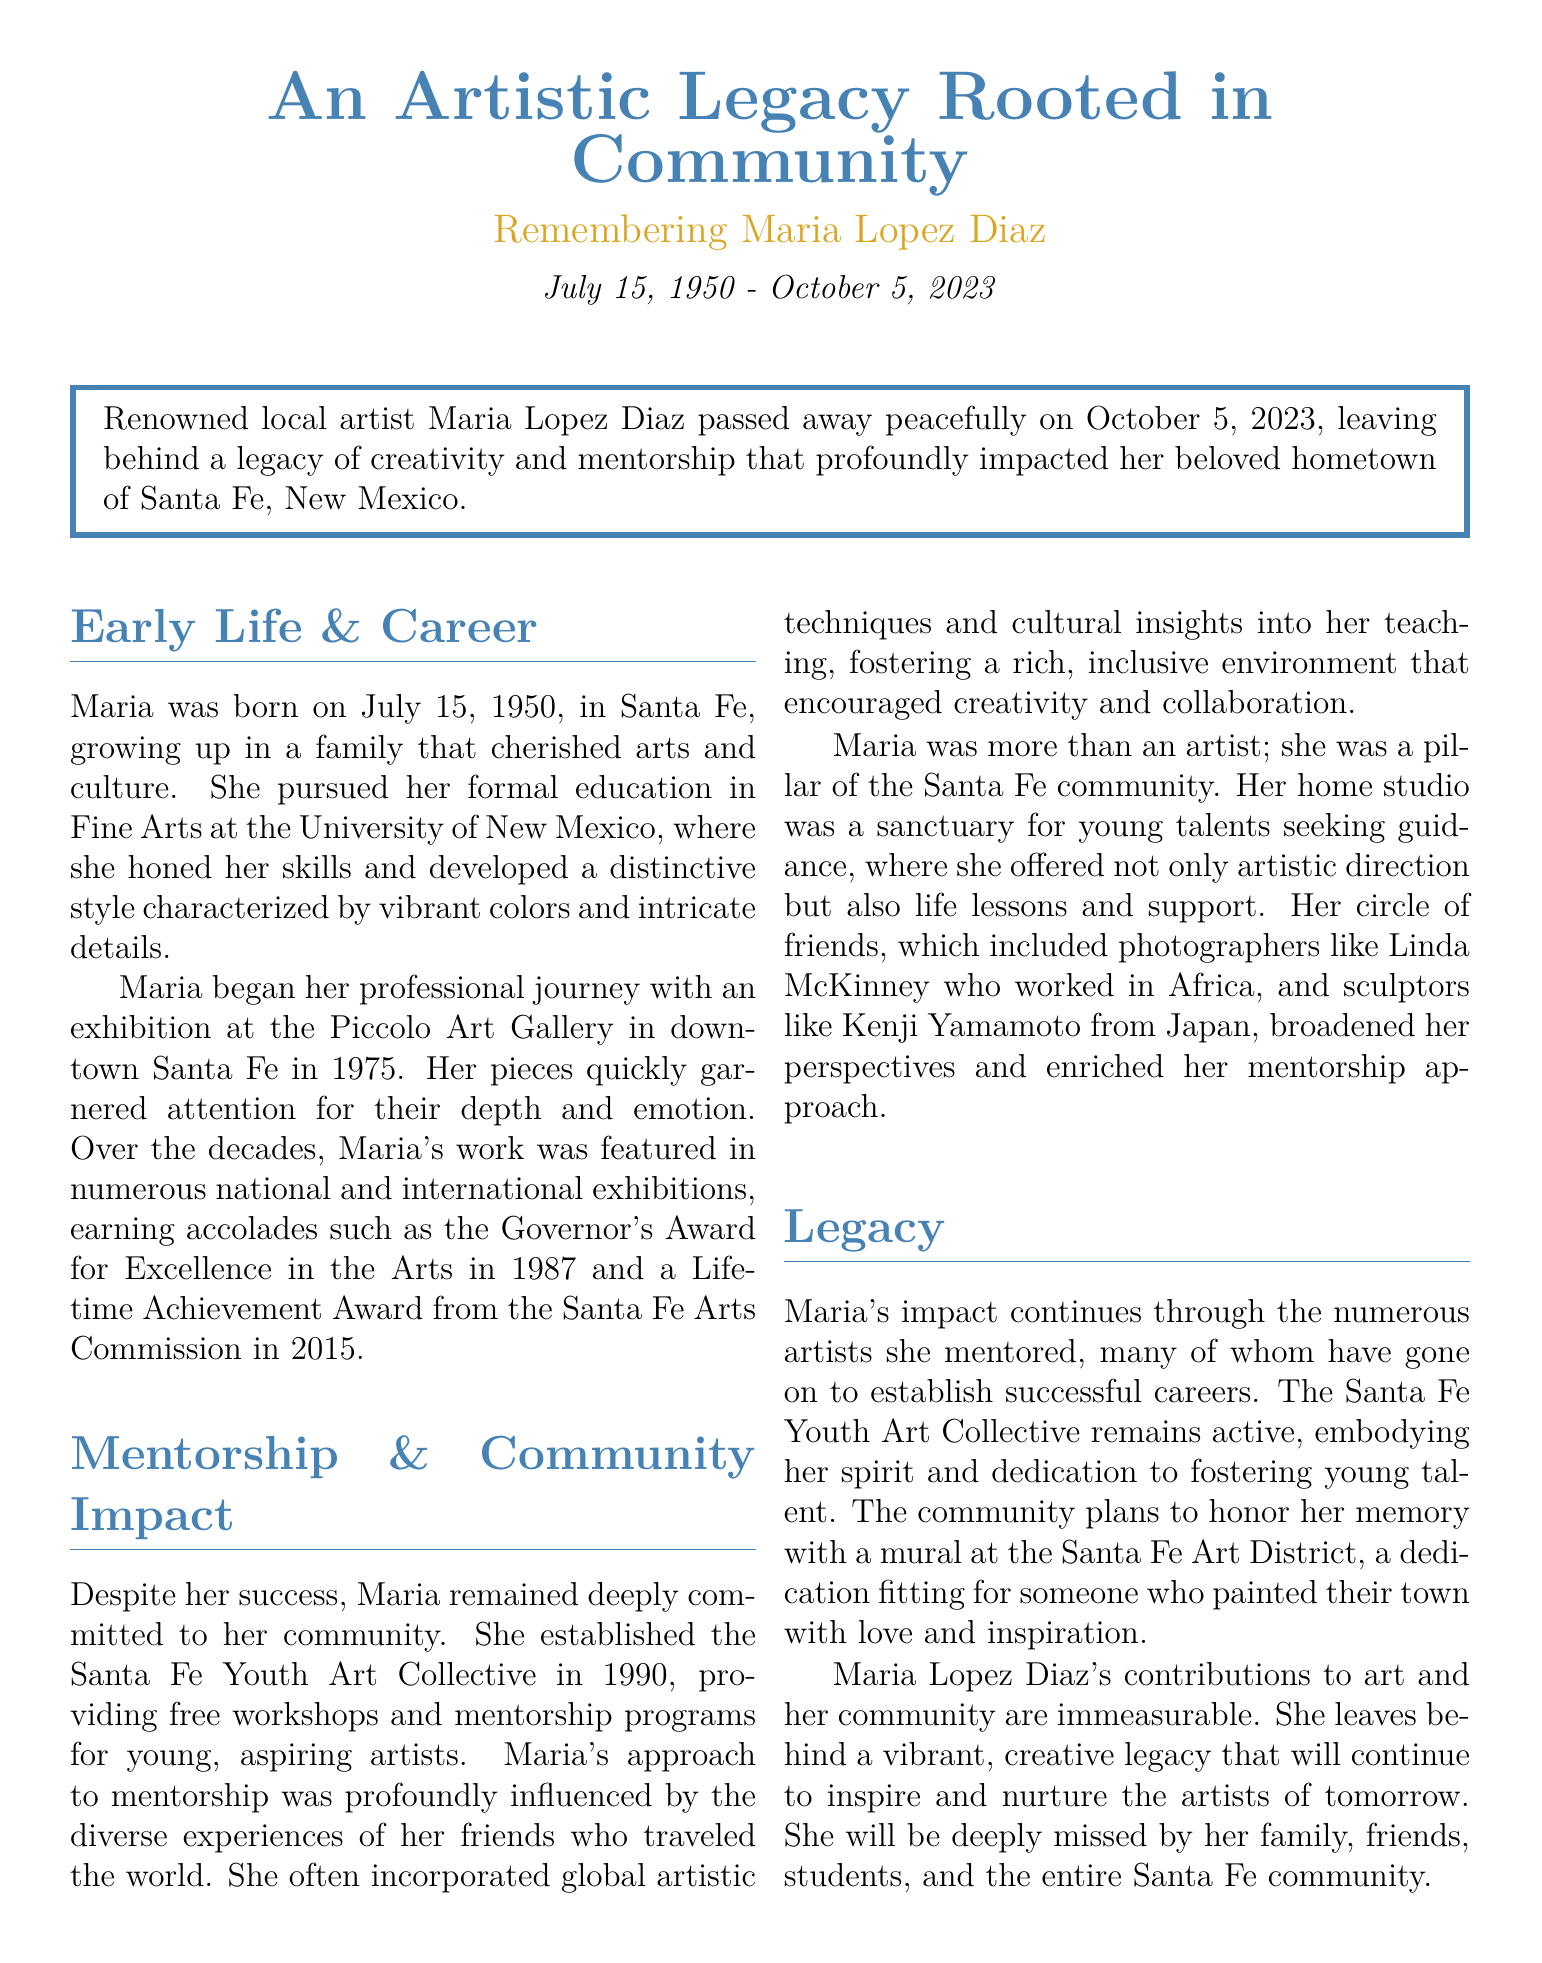what is the full name of the artist? The document states that the renowned local artist is Maria Lopez Diaz.
Answer: Maria Lopez Diaz when was Maria Lopez Diaz born? The document mentions her birth date as July 15, 1950.
Answer: July 15, 1950 what prestigious award did Maria receive in 1987? The document indicates she received the Governor's Award for Excellence in the Arts in 1987.
Answer: Governor's Award for Excellence in the Arts what did Maria establish in 1990? The document describes that Maria established the Santa Fe Youth Art Collective in 1990.
Answer: Santa Fe Youth Art Collective who was one of Maria's friends that worked in Africa? The document lists Linda McKinney as a friend working in Africa.
Answer: Linda McKinney how many years after her birth did Maria pass away? The document states she passed away on October 5, 2023, making it 73 years after her birth in 1950.
Answer: 73 years what type of workshops did Maria provide? The document states that she provided free workshops and mentorship programs for young artists.
Answer: Free workshops what is planned to honor Maria's memory? The document mentions a mural at the Santa Fe Art District is planned to honor her memory.
Answer: A mural what was Maria's approach to mentorship primarily influenced by? The document indicates that her approach to mentorship was influenced by the diverse experiences of her friends.
Answer: Diverse experiences of her friends 